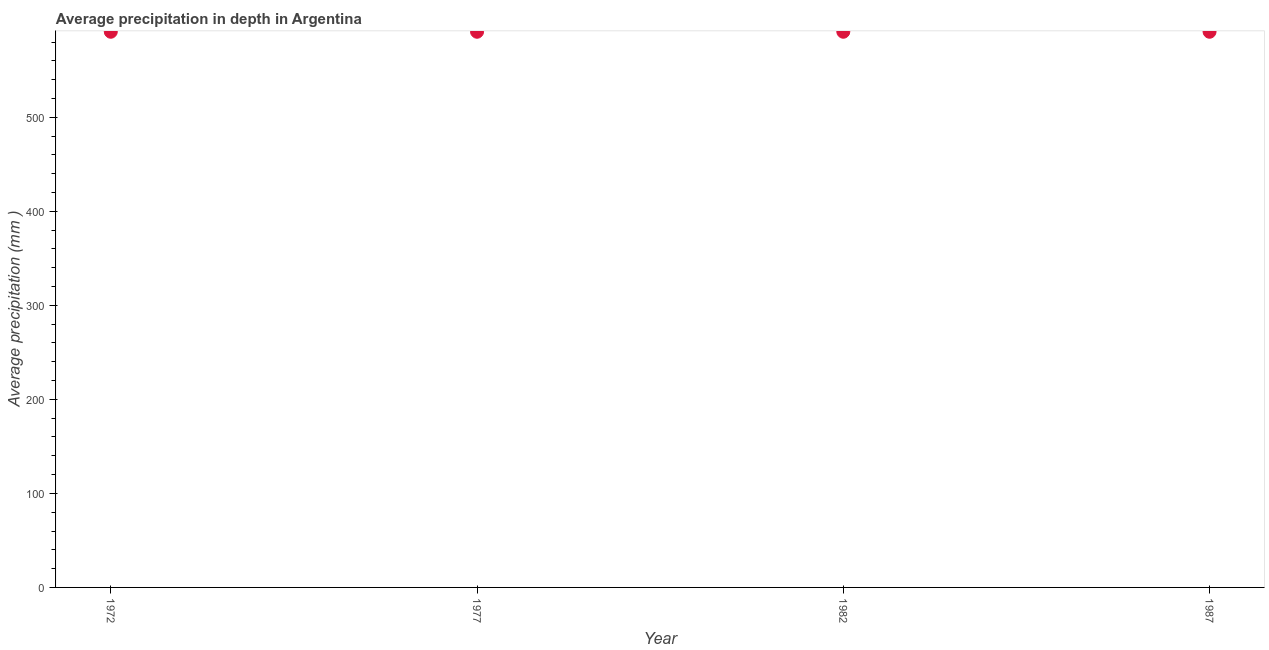What is the average precipitation in depth in 1987?
Keep it short and to the point. 591. Across all years, what is the maximum average precipitation in depth?
Ensure brevity in your answer.  591. Across all years, what is the minimum average precipitation in depth?
Offer a terse response. 591. In which year was the average precipitation in depth minimum?
Offer a very short reply. 1972. What is the sum of the average precipitation in depth?
Give a very brief answer. 2364. What is the difference between the average precipitation in depth in 1972 and 1977?
Ensure brevity in your answer.  0. What is the average average precipitation in depth per year?
Keep it short and to the point. 591. What is the median average precipitation in depth?
Offer a very short reply. 591. Is the sum of the average precipitation in depth in 1972 and 1982 greater than the maximum average precipitation in depth across all years?
Offer a terse response. Yes. Are the values on the major ticks of Y-axis written in scientific E-notation?
Your answer should be very brief. No. What is the title of the graph?
Ensure brevity in your answer.  Average precipitation in depth in Argentina. What is the label or title of the X-axis?
Keep it short and to the point. Year. What is the label or title of the Y-axis?
Make the answer very short. Average precipitation (mm ). What is the Average precipitation (mm ) in 1972?
Your response must be concise. 591. What is the Average precipitation (mm ) in 1977?
Your answer should be compact. 591. What is the Average precipitation (mm ) in 1982?
Keep it short and to the point. 591. What is the Average precipitation (mm ) in 1987?
Ensure brevity in your answer.  591. What is the difference between the Average precipitation (mm ) in 1972 and 1987?
Your answer should be compact. 0. What is the difference between the Average precipitation (mm ) in 1982 and 1987?
Provide a short and direct response. 0. What is the ratio of the Average precipitation (mm ) in 1977 to that in 1982?
Offer a terse response. 1. What is the ratio of the Average precipitation (mm ) in 1977 to that in 1987?
Keep it short and to the point. 1. What is the ratio of the Average precipitation (mm ) in 1982 to that in 1987?
Your response must be concise. 1. 